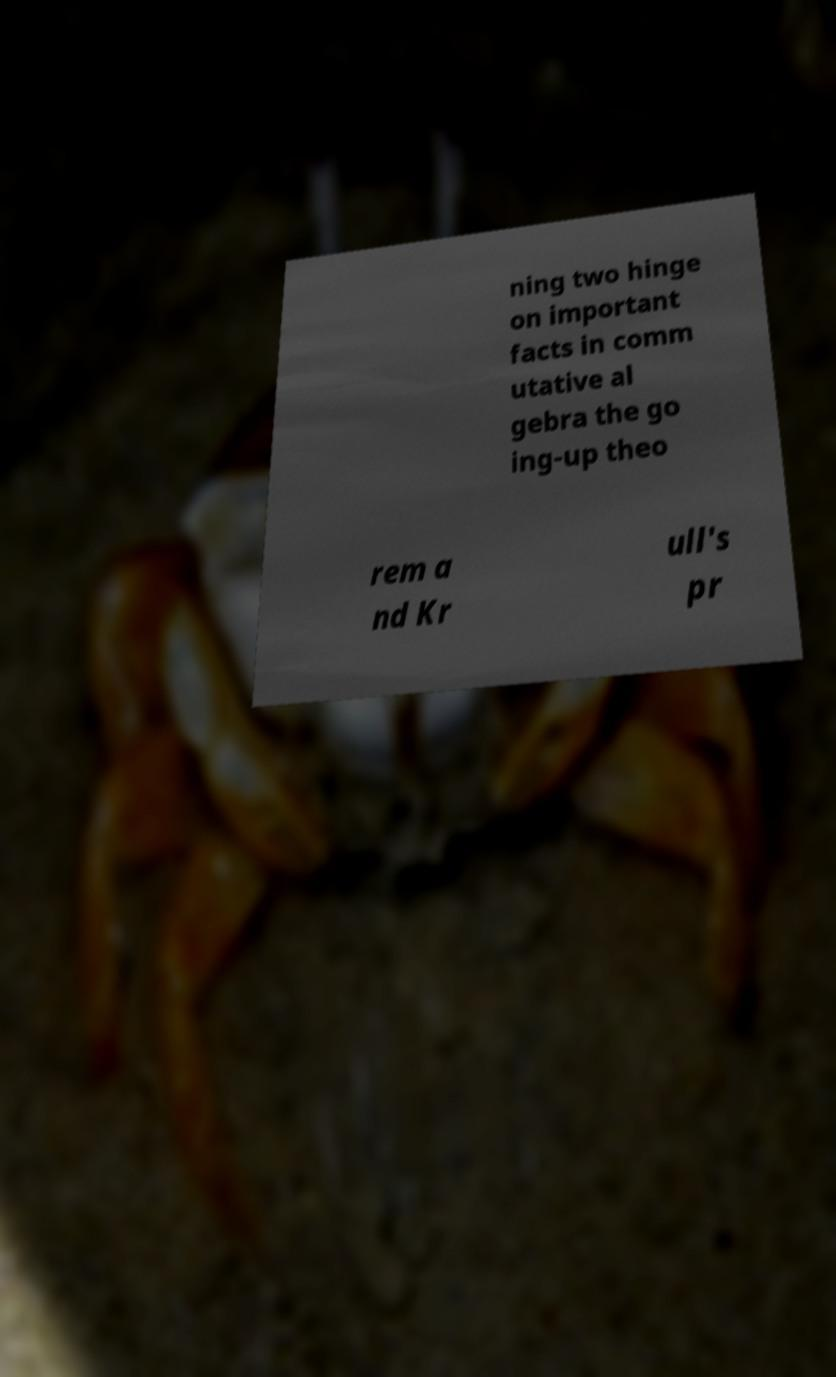Could you assist in decoding the text presented in this image and type it out clearly? ning two hinge on important facts in comm utative al gebra the go ing-up theo rem a nd Kr ull's pr 